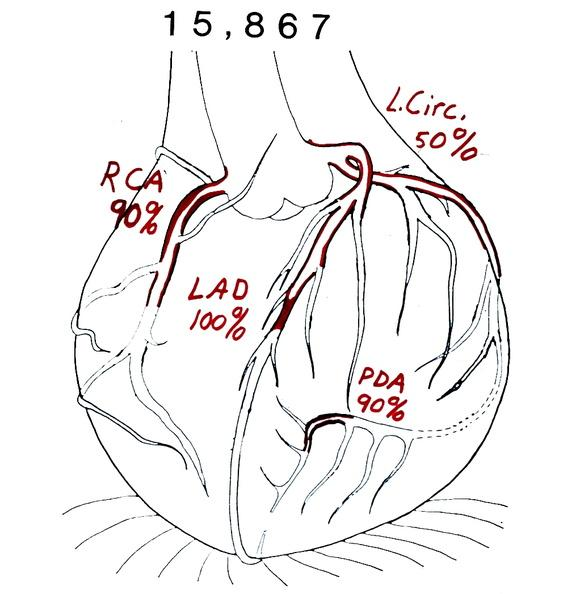s cardiovascular present?
Answer the question using a single word or phrase. Yes 